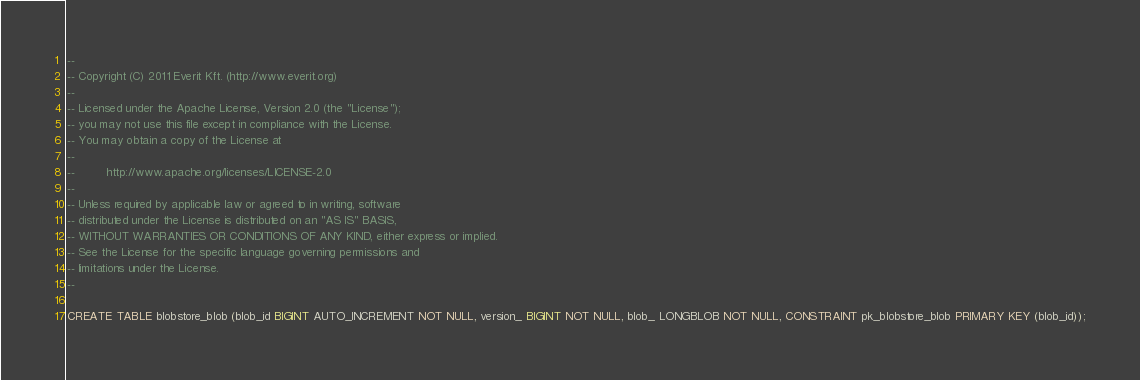<code> <loc_0><loc_0><loc_500><loc_500><_SQL_>--
-- Copyright (C) 2011 Everit Kft. (http://www.everit.org)
--
-- Licensed under the Apache License, Version 2.0 (the "License");
-- you may not use this file except in compliance with the License.
-- You may obtain a copy of the License at
--
--         http://www.apache.org/licenses/LICENSE-2.0
--
-- Unless required by applicable law or agreed to in writing, software
-- distributed under the License is distributed on an "AS IS" BASIS,
-- WITHOUT WARRANTIES OR CONDITIONS OF ANY KIND, either express or implied.
-- See the License for the specific language governing permissions and
-- limitations under the License.
--

CREATE TABLE blobstore_blob (blob_id BIGINT AUTO_INCREMENT NOT NULL, version_ BIGINT NOT NULL, blob_ LONGBLOB NOT NULL, CONSTRAINT pk_blobstore_blob PRIMARY KEY (blob_id));
</code> 